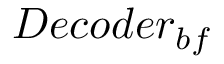<formula> <loc_0><loc_0><loc_500><loc_500>D e c o d e r _ { b f }</formula> 